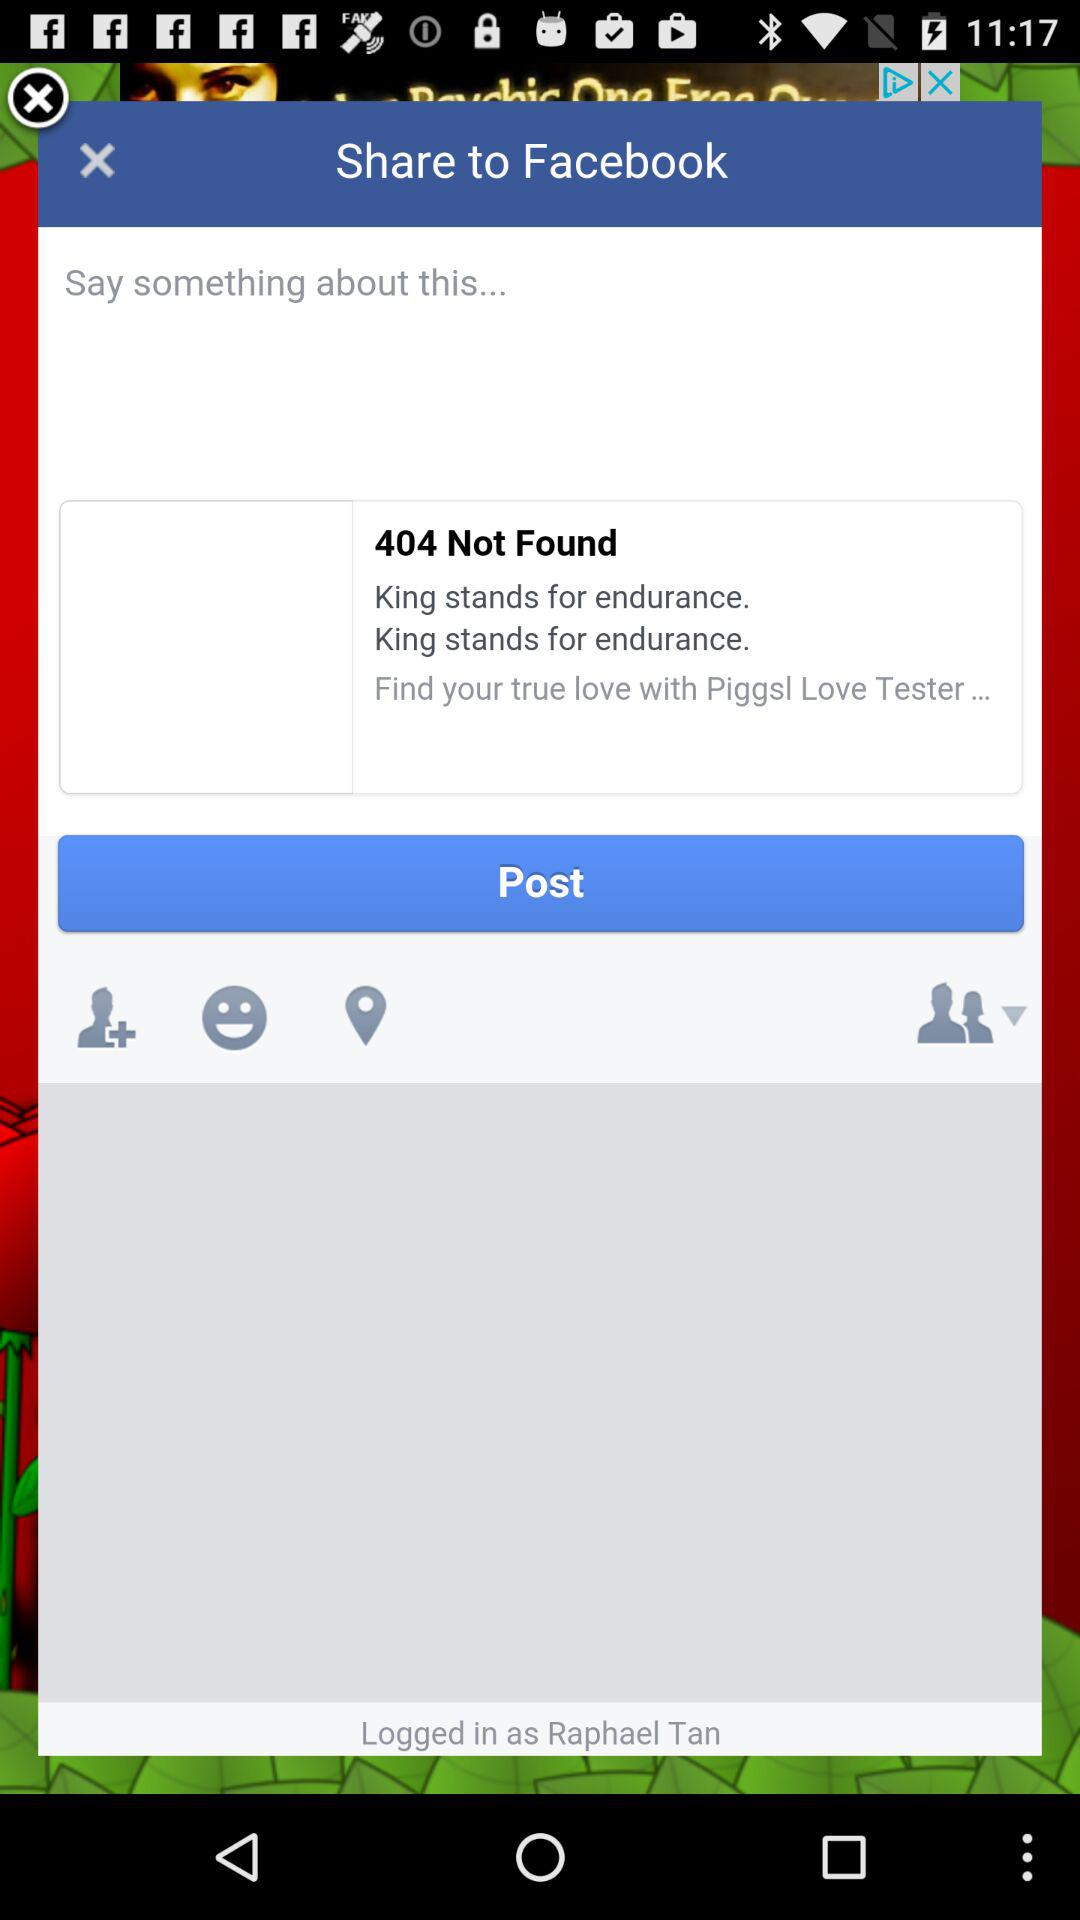Through what application can you share? The application is "Facebook". 